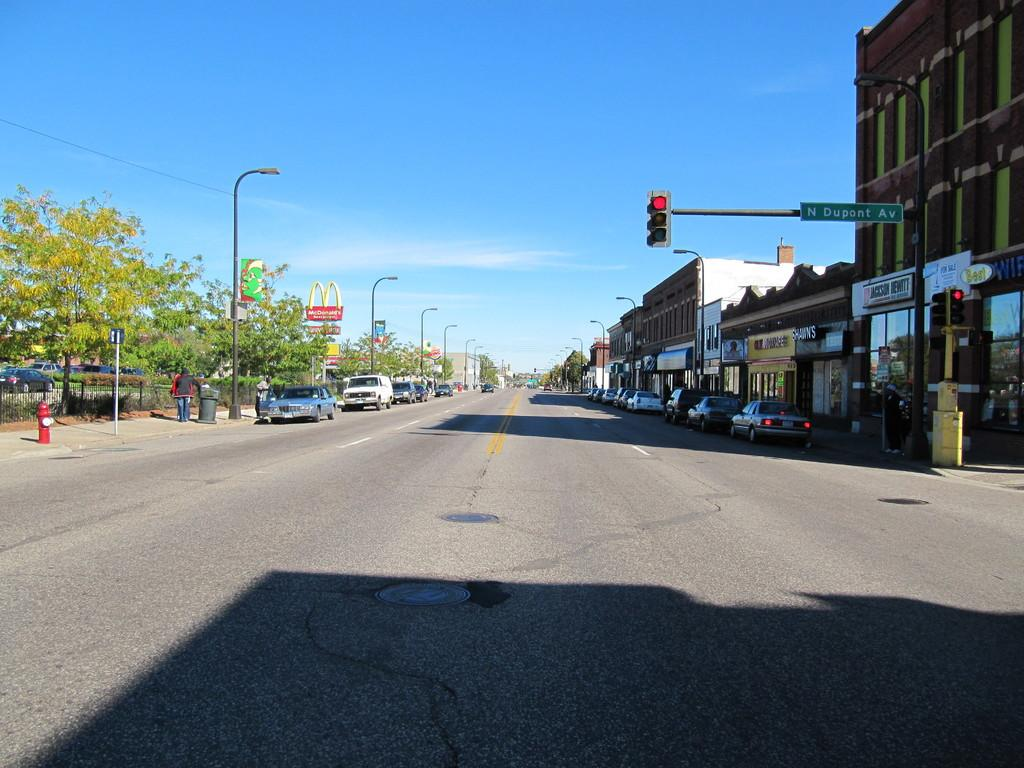<image>
Describe the image concisely. A city street with a traffic light and a street sign for N Dupont Avenue. 